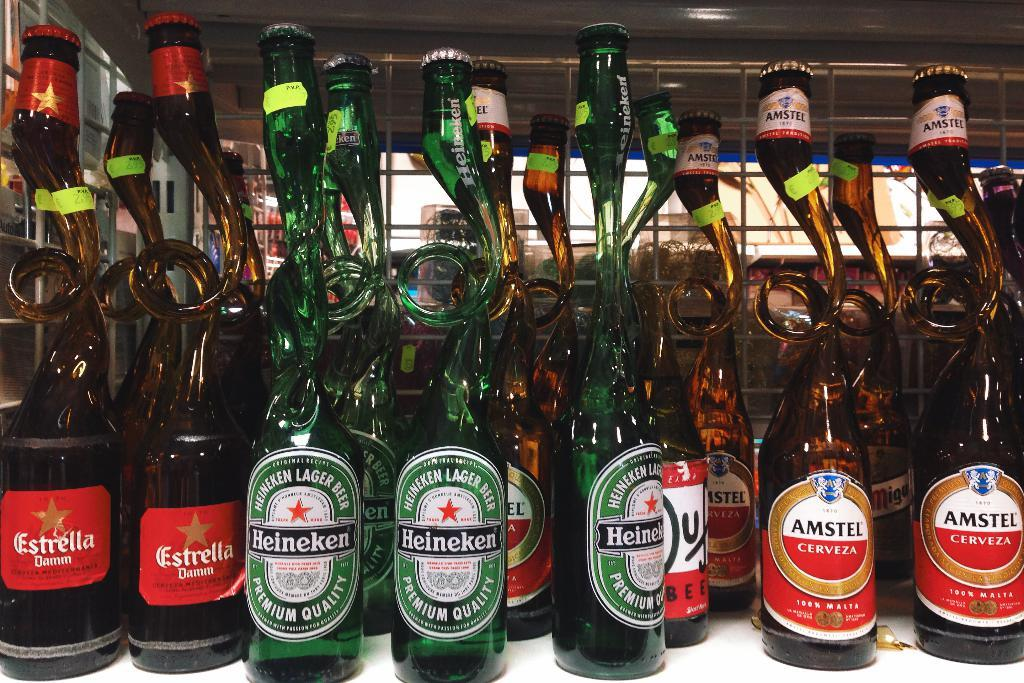<image>
Render a clear and concise summary of the photo. A bunch of beer on a counter some of which are made by Amstel and Heineken. 